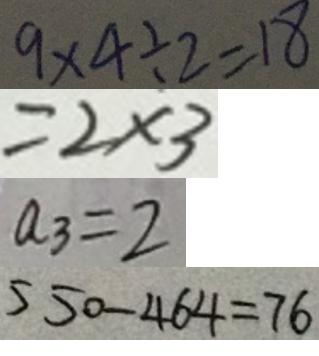<formula> <loc_0><loc_0><loc_500><loc_500>9 \times 4 \div 2 = 1 8 
 = 2 \times 3 
 a _ { 3 } = 2 
 5 5 0 - 4 6 4 = 7 6</formula> 